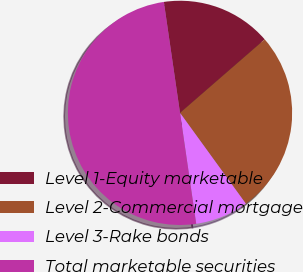Convert chart. <chart><loc_0><loc_0><loc_500><loc_500><pie_chart><fcel>Level 1-Equity marketable<fcel>Level 2-Commercial mortgage<fcel>Level 3-Rake bonds<fcel>Total marketable securities<nl><fcel>15.92%<fcel>26.4%<fcel>7.68%<fcel>50.0%<nl></chart> 